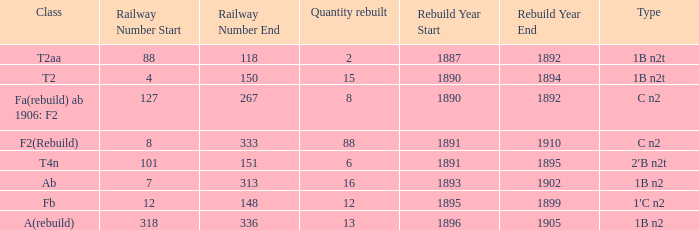What is the total of quantity rebuilt if the type is 1B N2T and the railway number is 88, 118? 1.0. 